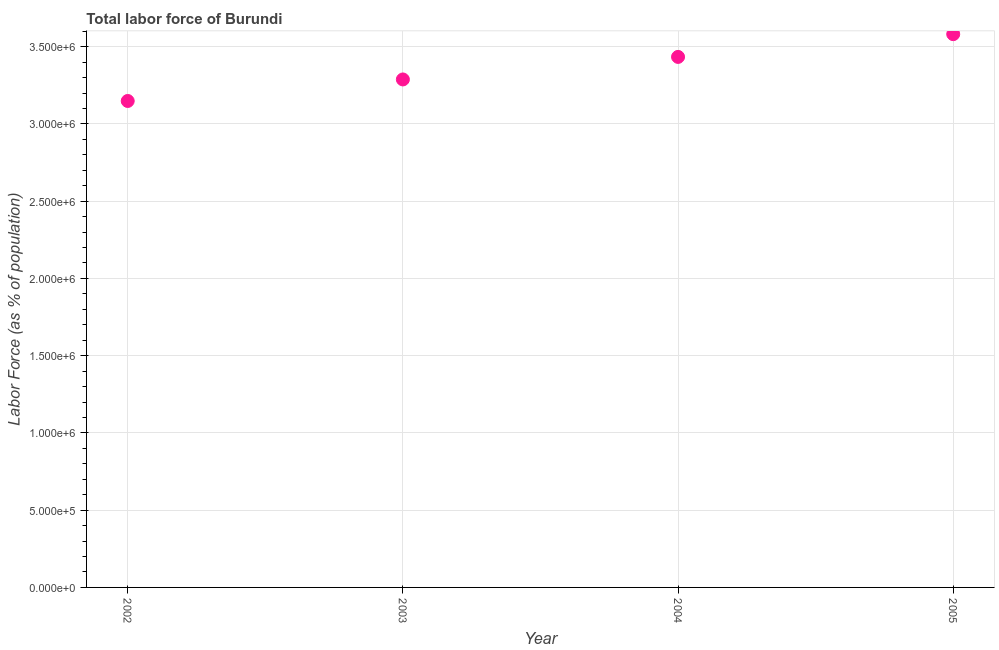What is the total labor force in 2002?
Provide a short and direct response. 3.15e+06. Across all years, what is the maximum total labor force?
Provide a succinct answer. 3.58e+06. Across all years, what is the minimum total labor force?
Give a very brief answer. 3.15e+06. In which year was the total labor force minimum?
Ensure brevity in your answer.  2002. What is the sum of the total labor force?
Provide a short and direct response. 1.35e+07. What is the difference between the total labor force in 2003 and 2004?
Ensure brevity in your answer.  -1.46e+05. What is the average total labor force per year?
Make the answer very short. 3.36e+06. What is the median total labor force?
Make the answer very short. 3.36e+06. Do a majority of the years between 2004 and 2002 (inclusive) have total labor force greater than 1200000 %?
Make the answer very short. No. What is the ratio of the total labor force in 2002 to that in 2005?
Ensure brevity in your answer.  0.88. Is the total labor force in 2003 less than that in 2005?
Offer a terse response. Yes. What is the difference between the highest and the second highest total labor force?
Your answer should be compact. 1.47e+05. What is the difference between the highest and the lowest total labor force?
Your answer should be very brief. 4.32e+05. In how many years, is the total labor force greater than the average total labor force taken over all years?
Provide a short and direct response. 2. Does the total labor force monotonically increase over the years?
Keep it short and to the point. Yes. How many years are there in the graph?
Your answer should be compact. 4. What is the title of the graph?
Your response must be concise. Total labor force of Burundi. What is the label or title of the Y-axis?
Your answer should be very brief. Labor Force (as % of population). What is the Labor Force (as % of population) in 2002?
Offer a very short reply. 3.15e+06. What is the Labor Force (as % of population) in 2003?
Keep it short and to the point. 3.29e+06. What is the Labor Force (as % of population) in 2004?
Your answer should be compact. 3.43e+06. What is the Labor Force (as % of population) in 2005?
Your answer should be very brief. 3.58e+06. What is the difference between the Labor Force (as % of population) in 2002 and 2003?
Your answer should be very brief. -1.39e+05. What is the difference between the Labor Force (as % of population) in 2002 and 2004?
Keep it short and to the point. -2.85e+05. What is the difference between the Labor Force (as % of population) in 2002 and 2005?
Your response must be concise. -4.32e+05. What is the difference between the Labor Force (as % of population) in 2003 and 2004?
Make the answer very short. -1.46e+05. What is the difference between the Labor Force (as % of population) in 2003 and 2005?
Offer a very short reply. -2.93e+05. What is the difference between the Labor Force (as % of population) in 2004 and 2005?
Your response must be concise. -1.47e+05. What is the ratio of the Labor Force (as % of population) in 2002 to that in 2003?
Make the answer very short. 0.96. What is the ratio of the Labor Force (as % of population) in 2002 to that in 2004?
Your answer should be compact. 0.92. What is the ratio of the Labor Force (as % of population) in 2002 to that in 2005?
Provide a succinct answer. 0.88. What is the ratio of the Labor Force (as % of population) in 2003 to that in 2004?
Your answer should be very brief. 0.96. What is the ratio of the Labor Force (as % of population) in 2003 to that in 2005?
Keep it short and to the point. 0.92. 